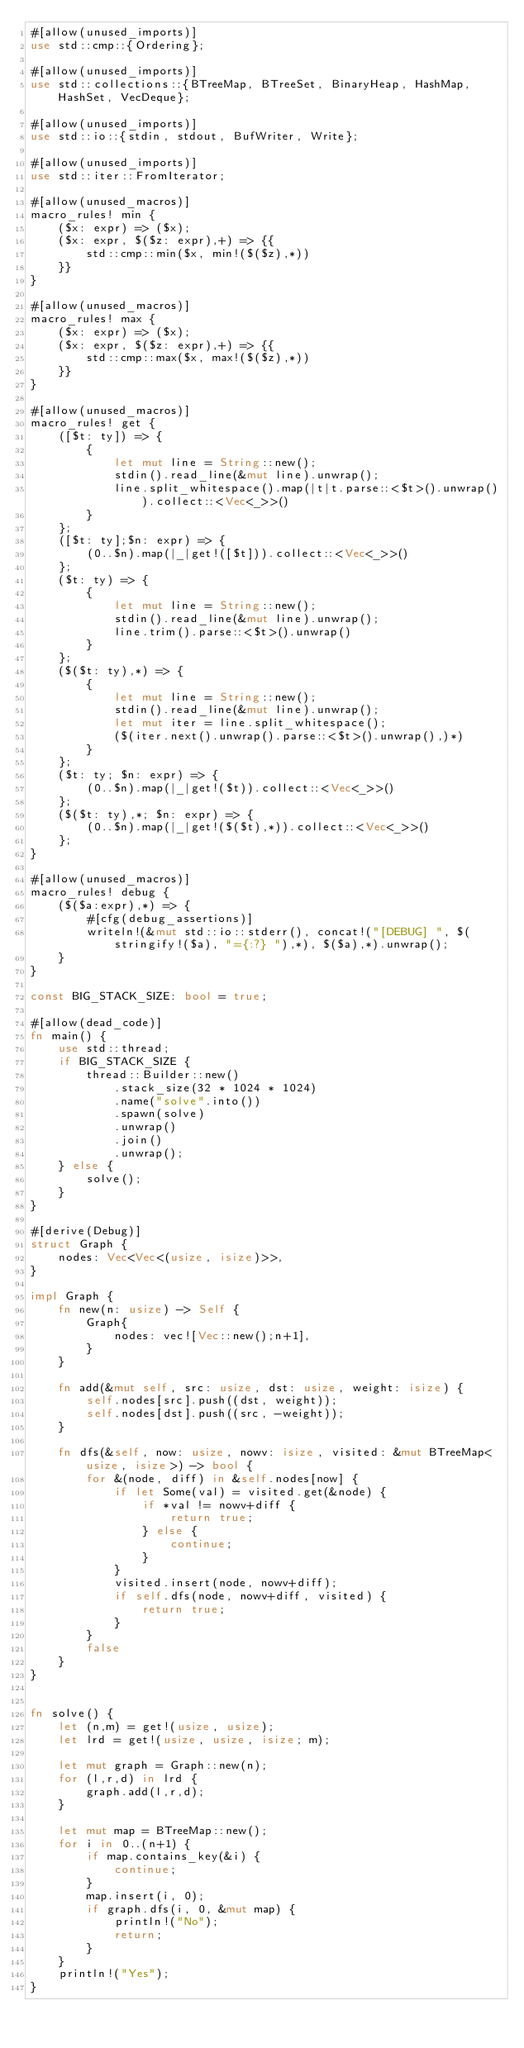Convert code to text. <code><loc_0><loc_0><loc_500><loc_500><_Rust_>#[allow(unused_imports)]
use std::cmp::{Ordering};

#[allow(unused_imports)]
use std::collections::{BTreeMap, BTreeSet, BinaryHeap, HashMap, HashSet, VecDeque};

#[allow(unused_imports)]
use std::io::{stdin, stdout, BufWriter, Write};

#[allow(unused_imports)]
use std::iter::FromIterator;

#[allow(unused_macros)]
macro_rules! min {
    ($x: expr) => ($x);
    ($x: expr, $($z: expr),+) => {{
        std::cmp::min($x, min!($($z),*))
    }}
}

#[allow(unused_macros)]
macro_rules! max {
    ($x: expr) => ($x);
    ($x: expr, $($z: expr),+) => {{
        std::cmp::max($x, max!($($z),*))
    }}
}

#[allow(unused_macros)]
macro_rules! get { 
    ([$t: ty]) => { 
        { 
            let mut line = String::new(); 
            stdin().read_line(&mut line).unwrap(); 
            line.split_whitespace().map(|t|t.parse::<$t>().unwrap()).collect::<Vec<_>>()
        }
    };
    ([$t: ty];$n: expr) => {
        (0..$n).map(|_|get!([$t])).collect::<Vec<_>>()
    };
    ($t: ty) => {
        {
            let mut line = String::new();
            stdin().read_line(&mut line).unwrap();
            line.trim().parse::<$t>().unwrap()
        }
    };
    ($($t: ty),*) => {
        { 
            let mut line = String::new();
            stdin().read_line(&mut line).unwrap();
            let mut iter = line.split_whitespace();
            ($(iter.next().unwrap().parse::<$t>().unwrap(),)*)
        }
    };
    ($t: ty; $n: expr) => {
        (0..$n).map(|_|get!($t)).collect::<Vec<_>>()
    };
    ($($t: ty),*; $n: expr) => {
        (0..$n).map(|_|get!($($t),*)).collect::<Vec<_>>()
    };
}

#[allow(unused_macros)]
macro_rules! debug {
    ($($a:expr),*) => {
        #[cfg(debug_assertions)]
        writeln!(&mut std::io::stderr(), concat!("[DEBUG] ", $(stringify!($a), "={:?} "),*), $($a),*).unwrap();
    }
}

const BIG_STACK_SIZE: bool = true;

#[allow(dead_code)]
fn main() {
    use std::thread;
    if BIG_STACK_SIZE {
        thread::Builder::new()
            .stack_size(32 * 1024 * 1024)
            .name("solve".into())
            .spawn(solve)
            .unwrap()
            .join()
            .unwrap();
    } else {
        solve();
    }
}

#[derive(Debug)]
struct Graph {
    nodes: Vec<Vec<(usize, isize)>>,
}

impl Graph {
    fn new(n: usize) -> Self {
        Graph{
            nodes: vec![Vec::new();n+1],
        }
    }

    fn add(&mut self, src: usize, dst: usize, weight: isize) {
        self.nodes[src].push((dst, weight));
        self.nodes[dst].push((src, -weight));
    }

    fn dfs(&self, now: usize, nowv: isize, visited: &mut BTreeMap<usize, isize>) -> bool {
        for &(node, diff) in &self.nodes[now] {
            if let Some(val) = visited.get(&node) {
                if *val != nowv+diff {
                    return true;
                } else {
                    continue;
                }
            }
            visited.insert(node, nowv+diff);
            if self.dfs(node, nowv+diff, visited) {
                return true;
            }
        }
        false
    }
}


fn solve() {
    let (n,m) = get!(usize, usize);
    let lrd = get!(usize, usize, isize; m);

    let mut graph = Graph::new(n);
    for (l,r,d) in lrd {
        graph.add(l,r,d);
    }

    let mut map = BTreeMap::new();
    for i in 0..(n+1) {
        if map.contains_key(&i) {
            continue;
        }
        map.insert(i, 0);
        if graph.dfs(i, 0, &mut map) {
            println!("No");
            return;
        }
    }
    println!("Yes");
}
</code> 